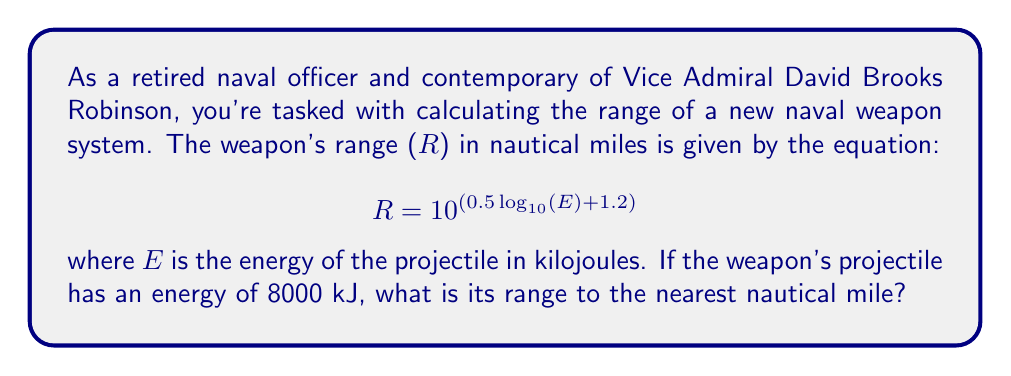Can you solve this math problem? Let's approach this step-by-step:

1) We're given the equation: $$ R = 10^{(0.5 \log_{10}(E) + 1.2)} $$

2) We know that E = 8000 kJ. Let's substitute this into the equation:

   $$ R = 10^{(0.5 \log_{10}(8000) + 1.2)} $$

3) First, let's calculate $\log_{10}(8000)$:
   
   $$ \log_{10}(8000) = 3.9031 $$

4) Now, let's substitute this back into our equation:

   $$ R = 10^{(0.5 \cdot 3.9031 + 1.2)} $$

5) Let's solve the exponent:
   
   $$ 0.5 \cdot 3.9031 + 1.2 = 1.9516 + 1.2 = 3.1516 $$

6) So now we have:

   $$ R = 10^{3.1516} $$

7) Calculate this:

   $$ R = 1417.7 $$

8) Rounding to the nearest nautical mile:

   $$ R \approx 1418 \text{ nautical miles} $$
Answer: The range of the naval weapon is approximately 1418 nautical miles. 